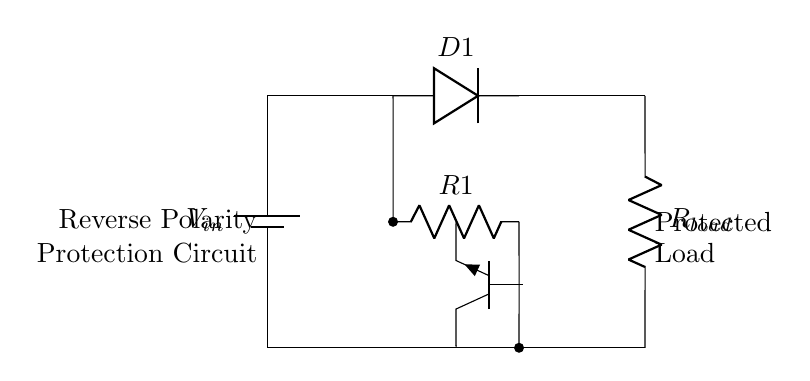What is the component labeled D1? D1 is a diode that allows current to flow in only one direction, providing protection against reverse polarity.
Answer: diode What does the resistor R1 do in the circuit? R1 serves as a current-limiting resistor that protects the transistor and helps in providing stability to the circuit during reverse polarity situations.
Answer: current-limiting resistor What type of transistor is used in the circuit? The circuit uses an NPN transistor, as indicated by the label "npn." This type of transistor allows current to flow when appropriate base current is present.
Answer: NPN How does the circuit protect against reverse polarity? The diode (D1) blocks current from flowing when the battery is incorrectly connected, preventing potential damage to the load and other components.
Answer: blocks the current What is the function of R_load in the circuit? R_load represents the load connected to the circuit, consuming the power provided by the battery while being protected from incorrect polarity.
Answer: load What happens when the input voltage is reversed? When input voltage is reversed, D1 becomes reverse-biased, stopping current flow and protecting the circuit from damage.
Answer: stops current flow What is the voltage source in the circuit? The voltage source in the circuit is represented by V_in, which supplies the power for the operation of the circuit and the load.
Answer: V_in 